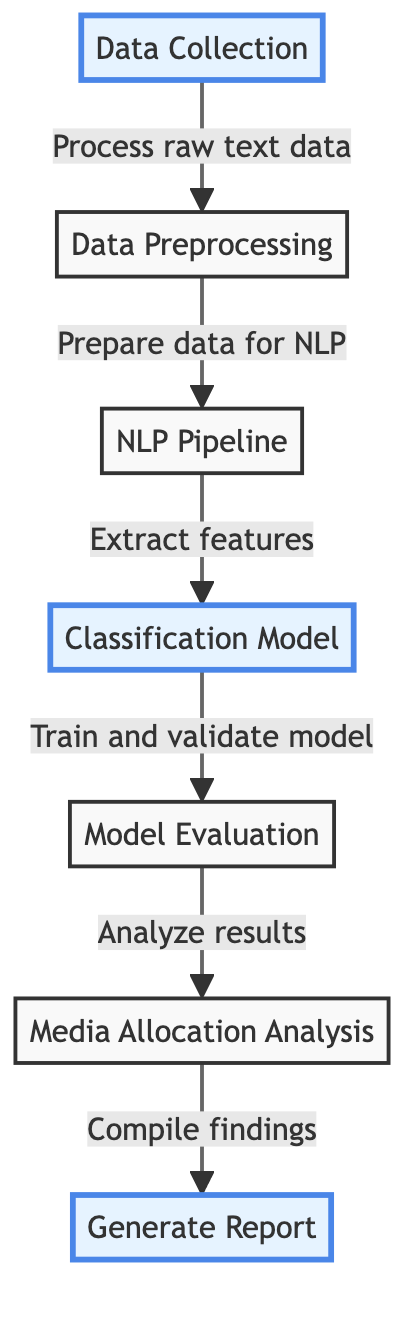What is the first step in the diagram? The first step according to the diagram is "Data Collection," which indicates that this is where the process begins.
Answer: Data Collection How many main steps are present in the diagram? By counting the nodes in the diagram, there are a total of seven main steps from "Data Collection" to "Generate Report."
Answer: Seven What node comes after the "NLP Pipeline"? After "NLP Pipeline," the next step in the diagram is "Classification Model," which indicates the flow of processes in this analysis.
Answer: Classification Model What is the role of the "Model Evaluation" step? "Model Evaluation" serves to analyze and assess the model's performance after training and validating, thereby providing insights before moving on to further analysis.
Answer: Analyze results Which three nodes are highlighted in the diagram? The highlighted nodes are "Data Collection," "Classification Model," and "Generate Report," which emphasize their significance in the overall process of evaluating media coverage.
Answer: Data Collection, Classification Model, Generate Report What is the final output of the diagram? The final output indicated in the diagram is "Generate Report," which suggests that the findings will be compiled and presented.
Answer: Generate Report Which node involves extracting features? The node that involves extracting features is "Classification Model," as it signifies applying the NLP techniques to distinguish various attributes from the collected data.
Answer: Classification Model What does the arrow from "Media Allocation Analysis" to "Generate Report" signify? The arrow signifies a flow from "Media Allocation Analysis" to "Generate Report," indicating that the findings compiled in the report are based on the analysis conducted.
Answer: Flow of findings What is the purpose of "Data Preprocessing"? "Data Preprocessing" is aimed at preparing raw text data for natural language processing, ensuring the data is clean and structured for analysis.
Answer: Preparing data for NLP 